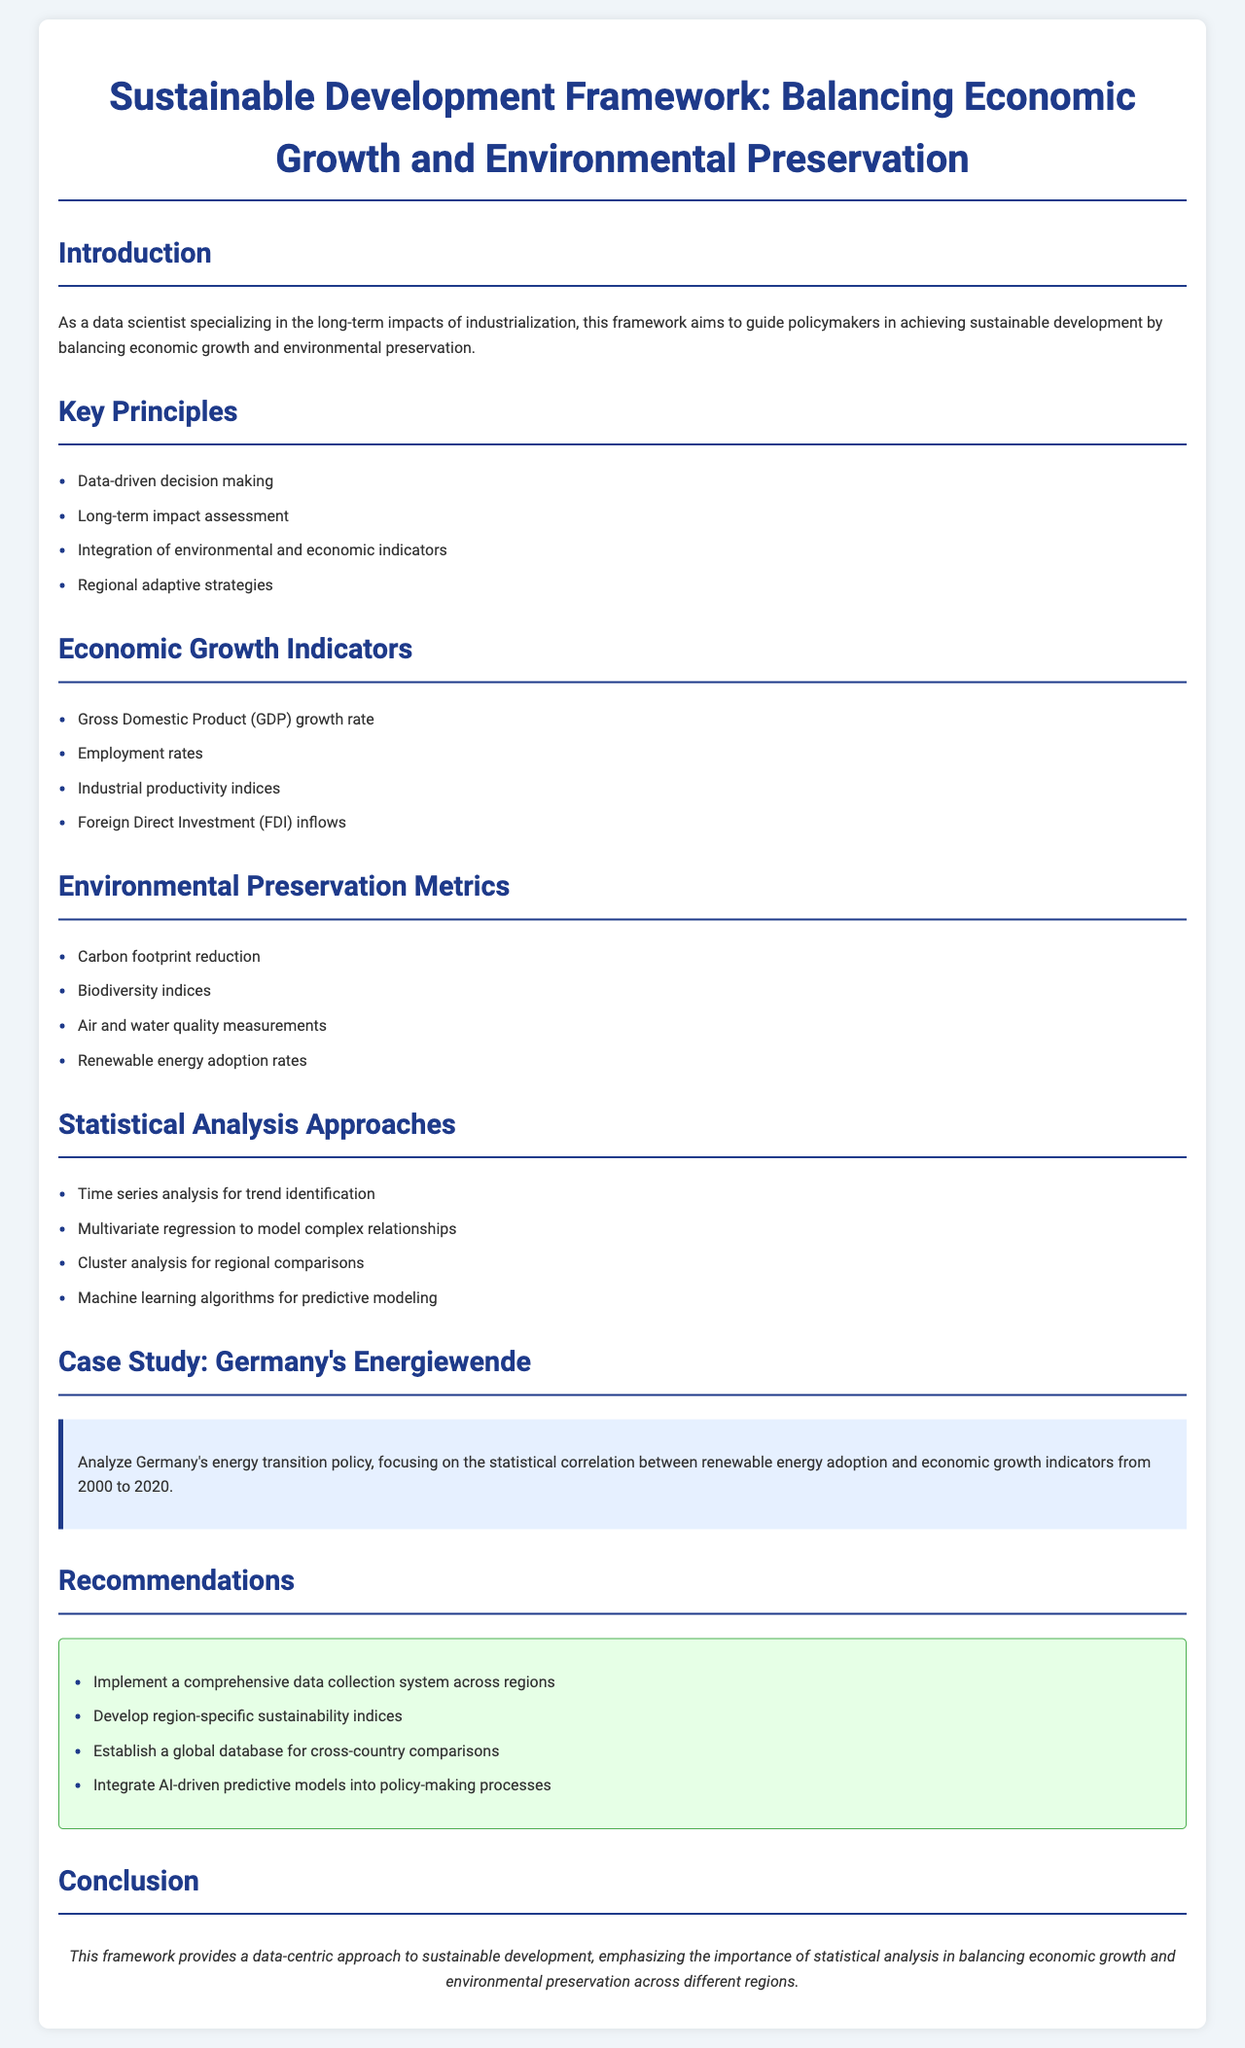What are the key principles of the framework? The key principles are listed under "Key Principles" in the document, which emphasizes core ideas guiding the framework.
Answer: Data-driven decision making, Long-term impact assessment, Integration of environmental and economic indicators, Regional adaptive strategies What is the case study mentioned in the document? The case study section highlights a specific example used to illustrate key concepts within the framework.
Answer: Germany's Energiewende What statistical analysis approaches are suggested? The document outlines statistical methods for analyzing data related to sustainable development, found under "Statistical Analysis Approaches."
Answer: Time series analysis, Multivariate regression, Cluster analysis, Machine learning algorithms What measurement is used for environmental preservation? The document presents metrics for evaluating environmental preservation under the "Environmental Preservation Metrics" section.
Answer: Carbon footprint reduction, Biodiversity indices, Air and water quality measurements, Renewable energy adoption rates How many economic growth indicators are listed? The count of indicators can be determined from the "Economic Growth Indicators" section's list format.
Answer: Four 